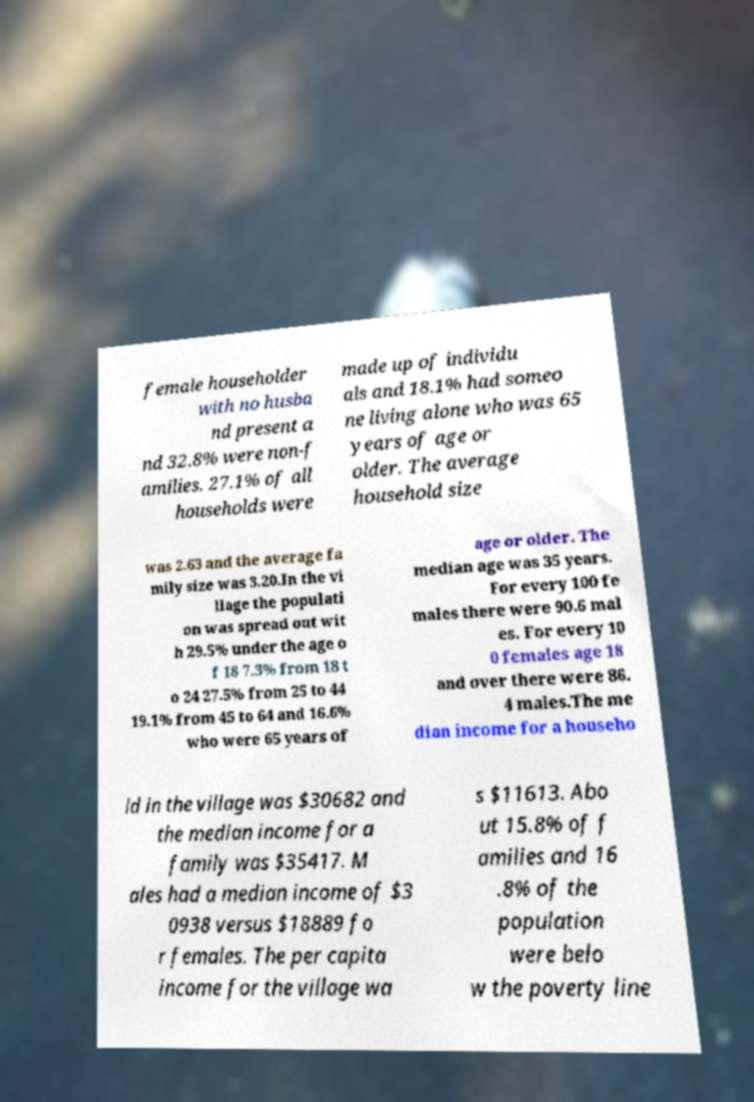I need the written content from this picture converted into text. Can you do that? female householder with no husba nd present a nd 32.8% were non-f amilies. 27.1% of all households were made up of individu als and 18.1% had someo ne living alone who was 65 years of age or older. The average household size was 2.63 and the average fa mily size was 3.20.In the vi llage the populati on was spread out wit h 29.5% under the age o f 18 7.3% from 18 t o 24 27.5% from 25 to 44 19.1% from 45 to 64 and 16.6% who were 65 years of age or older. The median age was 35 years. For every 100 fe males there were 90.6 mal es. For every 10 0 females age 18 and over there were 86. 4 males.The me dian income for a househo ld in the village was $30682 and the median income for a family was $35417. M ales had a median income of $3 0938 versus $18889 fo r females. The per capita income for the village wa s $11613. Abo ut 15.8% of f amilies and 16 .8% of the population were belo w the poverty line 